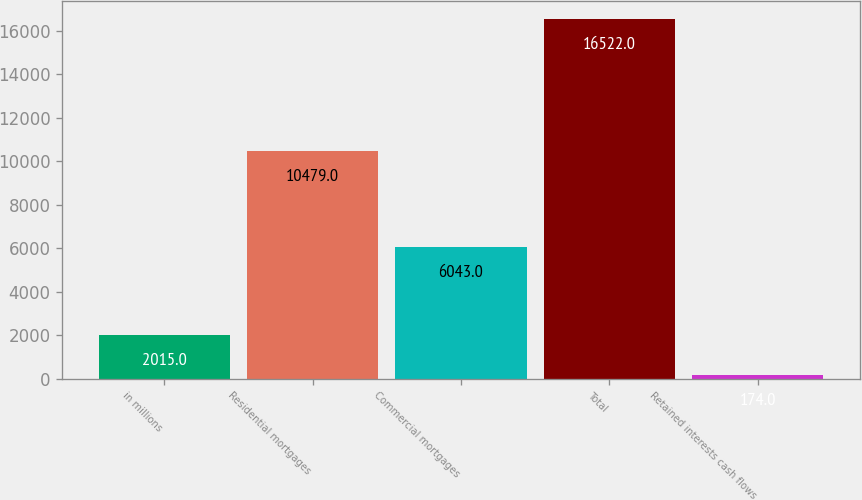<chart> <loc_0><loc_0><loc_500><loc_500><bar_chart><fcel>in millions<fcel>Residential mortgages<fcel>Commercial mortgages<fcel>Total<fcel>Retained interests cash flows<nl><fcel>2015<fcel>10479<fcel>6043<fcel>16522<fcel>174<nl></chart> 